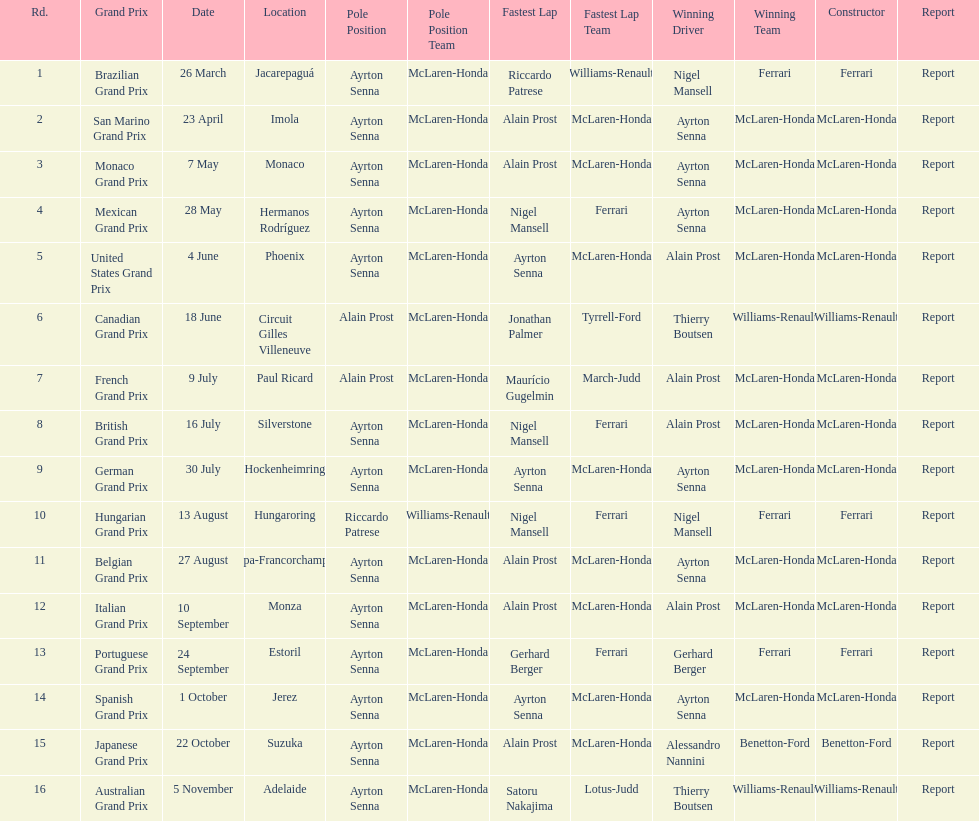What was the only grand prix to be won by benneton-ford? Japanese Grand Prix. 